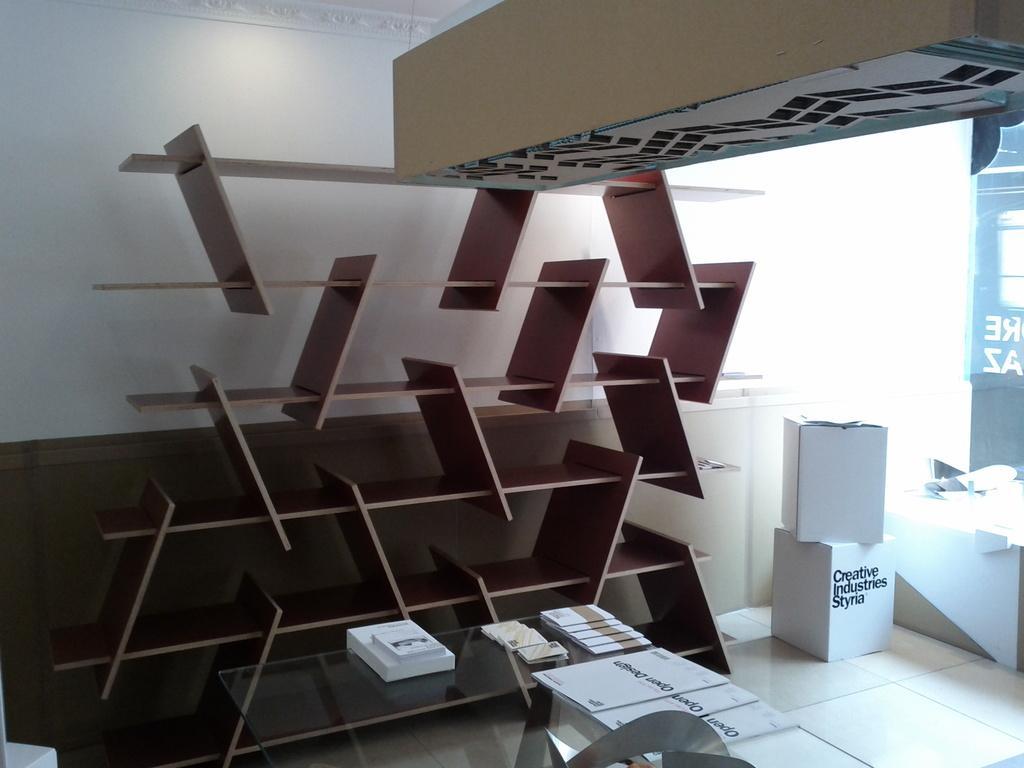Can you describe this image briefly? In this picture there is a cup board, made up of wood. And there is a table on which some papers and cards were placed. In the background there is a wall here. 